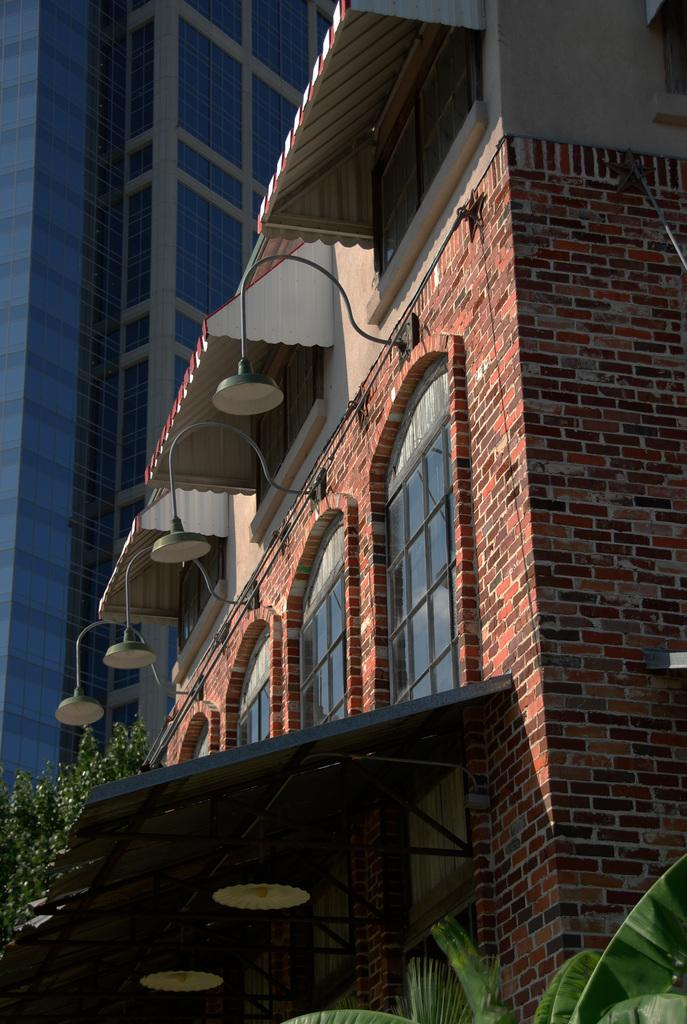What type of structure is depicted in the image? The image is of a building. What architectural feature can be seen on the building? The building has windows. Are there any lighting fixtures visible in the image? Yes, there are lamps attached to the wall. Can you describe the texture of the wall in the image? The wall has a brick texture. What type of natural element is visible in the image? Trees are visible in the image. How many floors does the building appear to have? The building appears to be a skyscraper with glass doors, suggesting it has multiple floors. Can you tell me how many volcanoes are visible in the image? There are no volcanoes visible in the image; it features a building with windows, lamps, a brick wall, trees, and glass doors. Is there a lawyer standing next to the building in the image? There is no lawyer present in the image; it only features the building and its surroundings. 